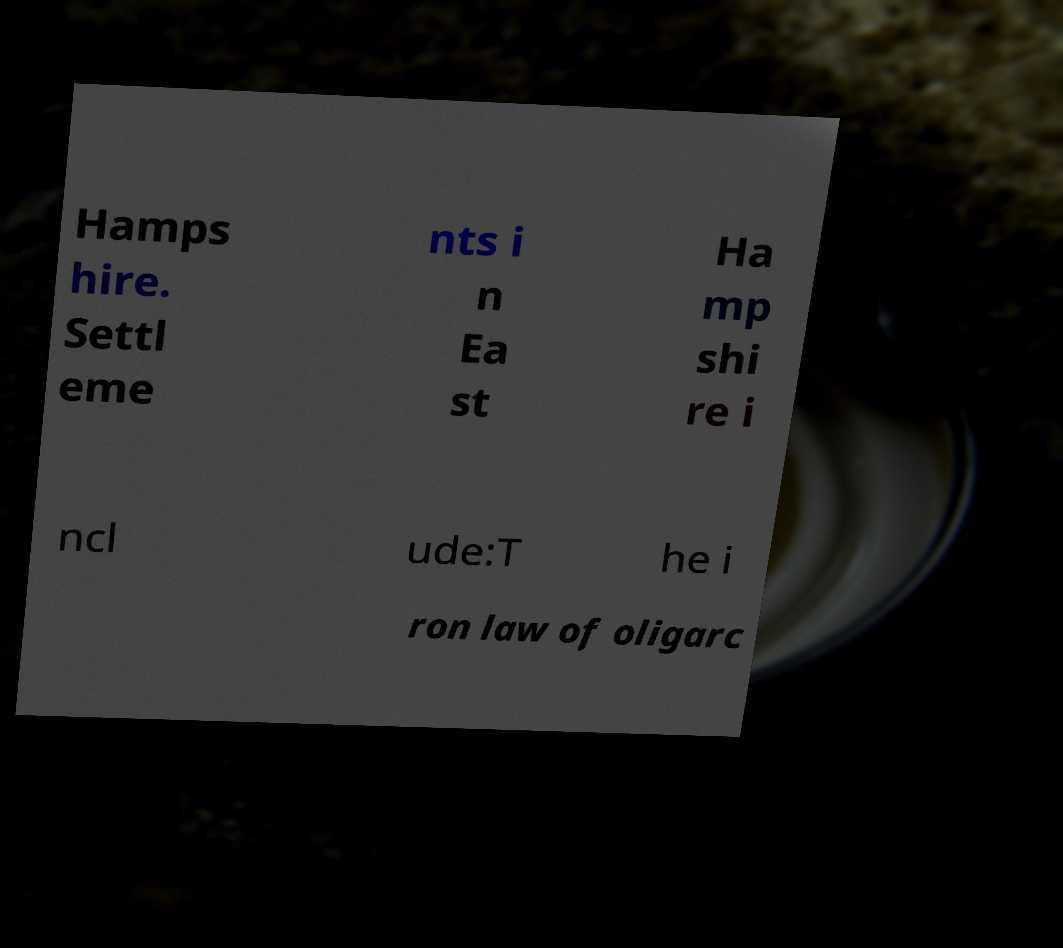Could you assist in decoding the text presented in this image and type it out clearly? Hamps hire. Settl eme nts i n Ea st Ha mp shi re i ncl ude:T he i ron law of oligarc 